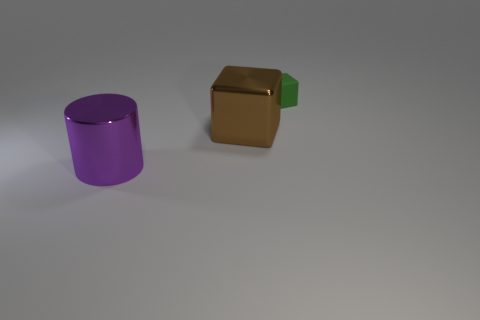Add 2 big gray spheres. How many objects exist? 5 Subtract all cylinders. How many objects are left? 2 Add 2 brown cubes. How many brown cubes exist? 3 Subtract 0 brown cylinders. How many objects are left? 3 Subtract all shiny objects. Subtract all big purple objects. How many objects are left? 0 Add 3 shiny things. How many shiny things are left? 5 